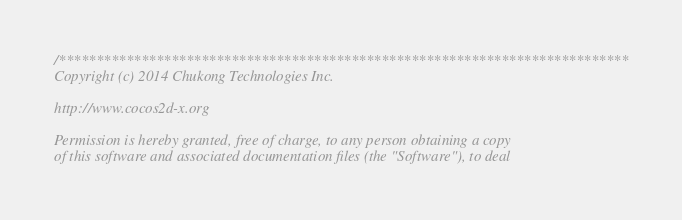<code> <loc_0><loc_0><loc_500><loc_500><_C++_>/****************************************************************************
Copyright (c) 2014 Chukong Technologies Inc.

http://www.cocos2d-x.org

Permission is hereby granted, free of charge, to any person obtaining a copy
of this software and associated documentation files (the "Software"), to deal</code> 